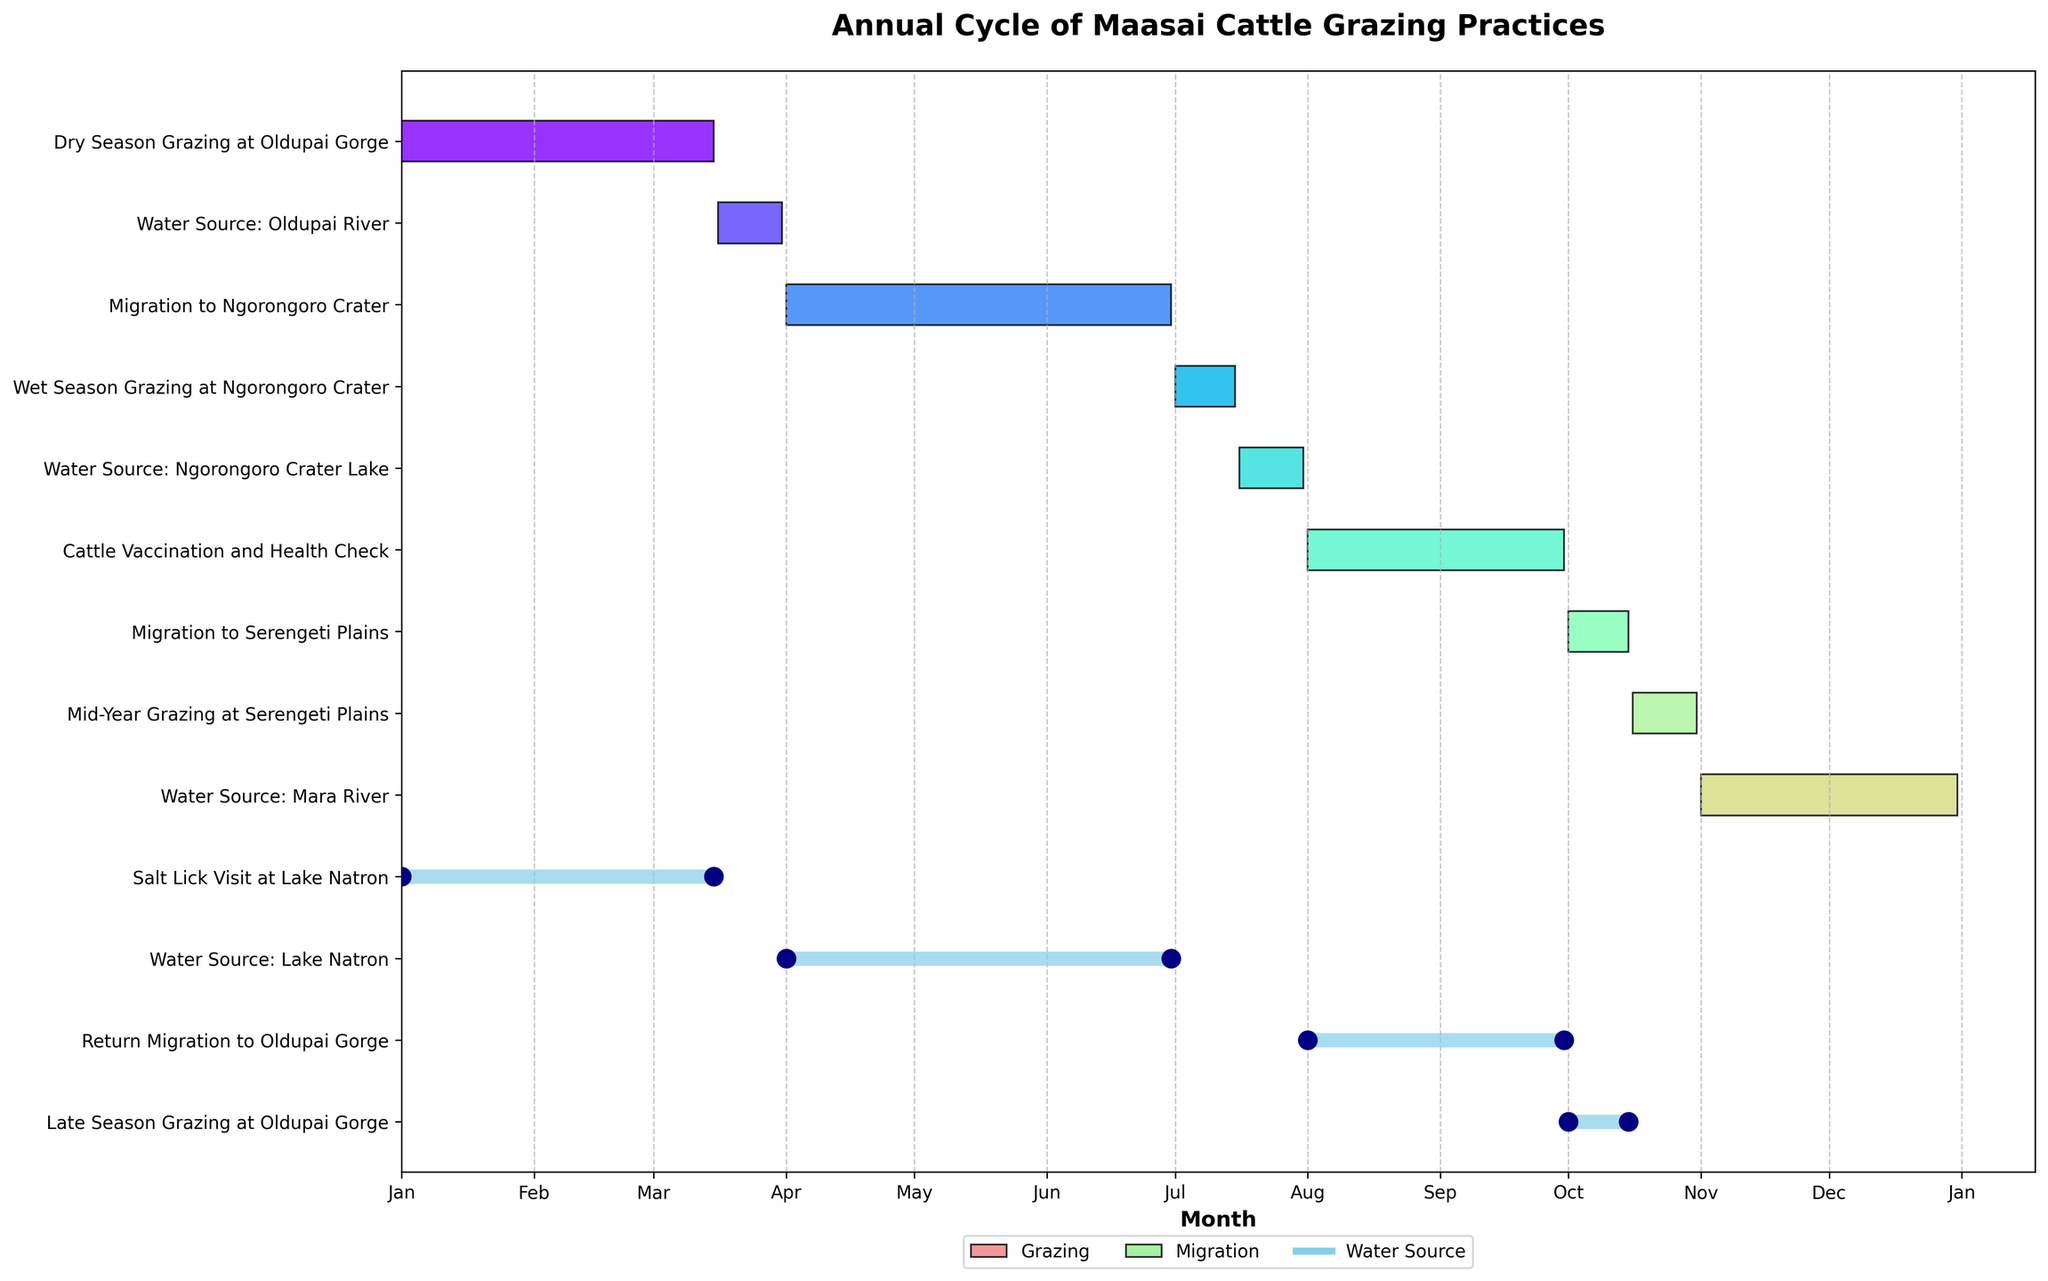What task starts in January? The task starts at the beginning of January. By looking at the first entry on the Gantt chart, we identify that "Dry Season Grazing at Oldupai Gorge" begins in January.
Answer: "Dry Season Grazing at Oldupai Gorge" Which month has the highest number of activities? To find the month with the highest number of activities, we count the number of activities occurring in each month. It appears that October has several overlapping tasks, including a "Salt Lick Visit at Lake Natron," a "Return Migration to Oldupai Gorge," and the continuing "Late Season Grazing at Oldupai Gorge".
Answer: October What is the duration of Wet Season Grazing at Ngorongoro Crater? The start date for Wet Season Grazing at Ngorongoro Crater is April 1st and the end date is June 30th. To find the duration, we calculate the difference between these two dates.
Answer: 91 days Which task overlaps with the Water Source: Oldupai River? The Water Source: Oldupai River runs from January 1st to March 15th. Checking the same time interval, we see that "Dry Season Grazing at Oldupai Gorge" overlaps entirely with this water source.
Answer: "Dry Season Grazing at Oldupai Gorge" What is the sequence of migration events? By examining the Gantt chart, we can identify the following migration sequence: "Migration to Ngorongoro Crater" from Mar 16 to Mar 31, "Migration to Serengeti Plains" from Jul 16 to Jul 31, and "Return Migration to Oldupai Gorge" from Oct 16 to Oct 31.
Answer: "Migration to Ngorongoro Crater" → "Migration to Serengeti Plains" → "Return Migration to Oldupai Gorge" During which months do cattle use the Mara River as a water source? We look for the task that indicates using the Mara River as a water source. According to the chart, Mara River is used from August 1st to September 30th.
Answer: August and September How long does Cattle Vaccination and Health Check last? The Cattle Vaccination and Health Check starts on July 1st and ends on July 15th. By calculating the difference between these dates, we determine the duration.
Answer: 15 days Which grazing period follows the Salt Lick Visit at Lake Natron? The Salt Lick Visit at Lake Natron ends on October 15th. The subsequent grazing period starts on November 1st at Oldupai Gorge, as identified on the timeline.
Answer: "Late Season Grazing at Oldupai Gorge" What are the two water sources used after July? Referencing the timeline following July, the two water sources utilized afterward are the Mara River and Lake Natron.
Answer: Mara River and Lake Natron 